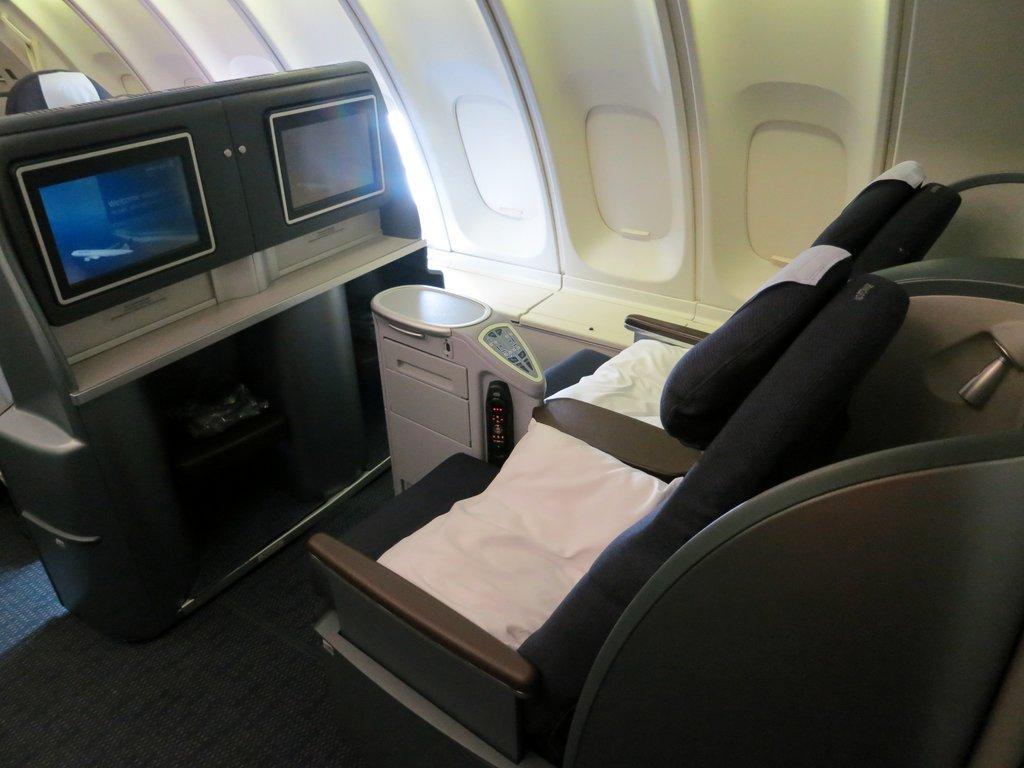Can you describe this image briefly? In this image I can see the inner part of the vehicle, I can also see two seats. In front I can see two screens. 